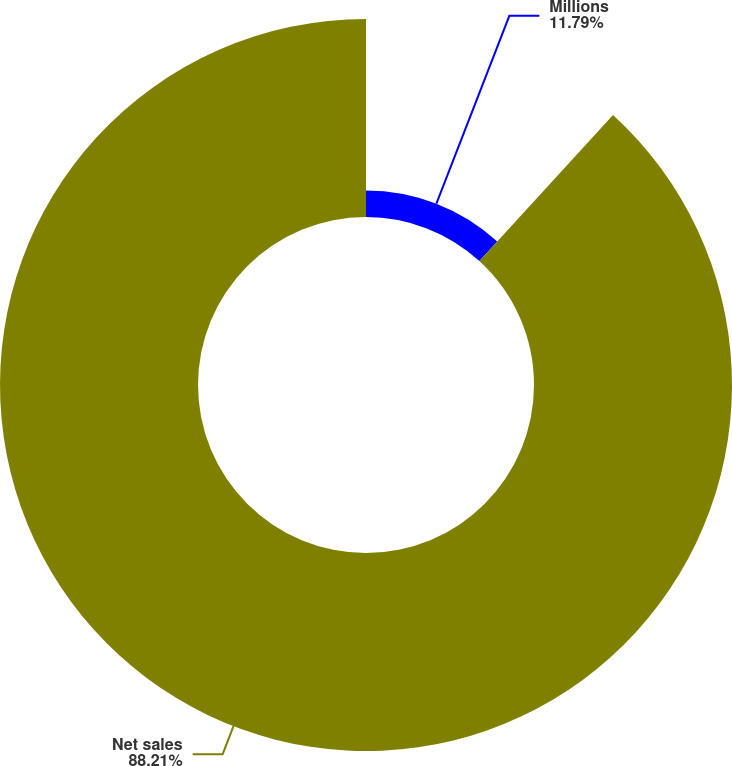<chart> <loc_0><loc_0><loc_500><loc_500><pie_chart><fcel>Millions<fcel>Net sales<nl><fcel>11.79%<fcel>88.21%<nl></chart> 